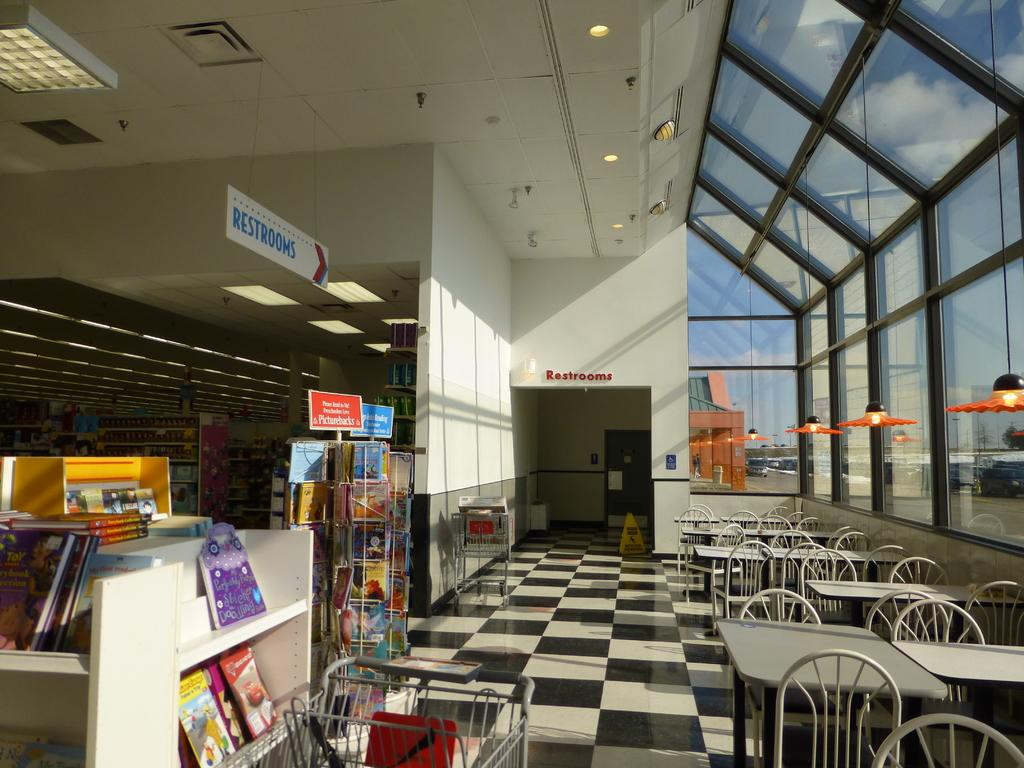<image>
Provide a brief description of the given image. A bookstore with a sign showing where the restrooms are. 